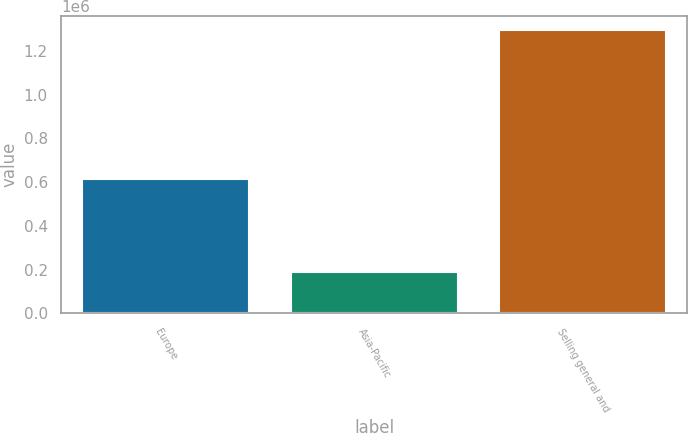Convert chart to OTSL. <chart><loc_0><loc_0><loc_500><loc_500><bar_chart><fcel>Europe<fcel>Asia-Pacific<fcel>Selling general and<nl><fcel>615966<fcel>188862<fcel>1.29501e+06<nl></chart> 